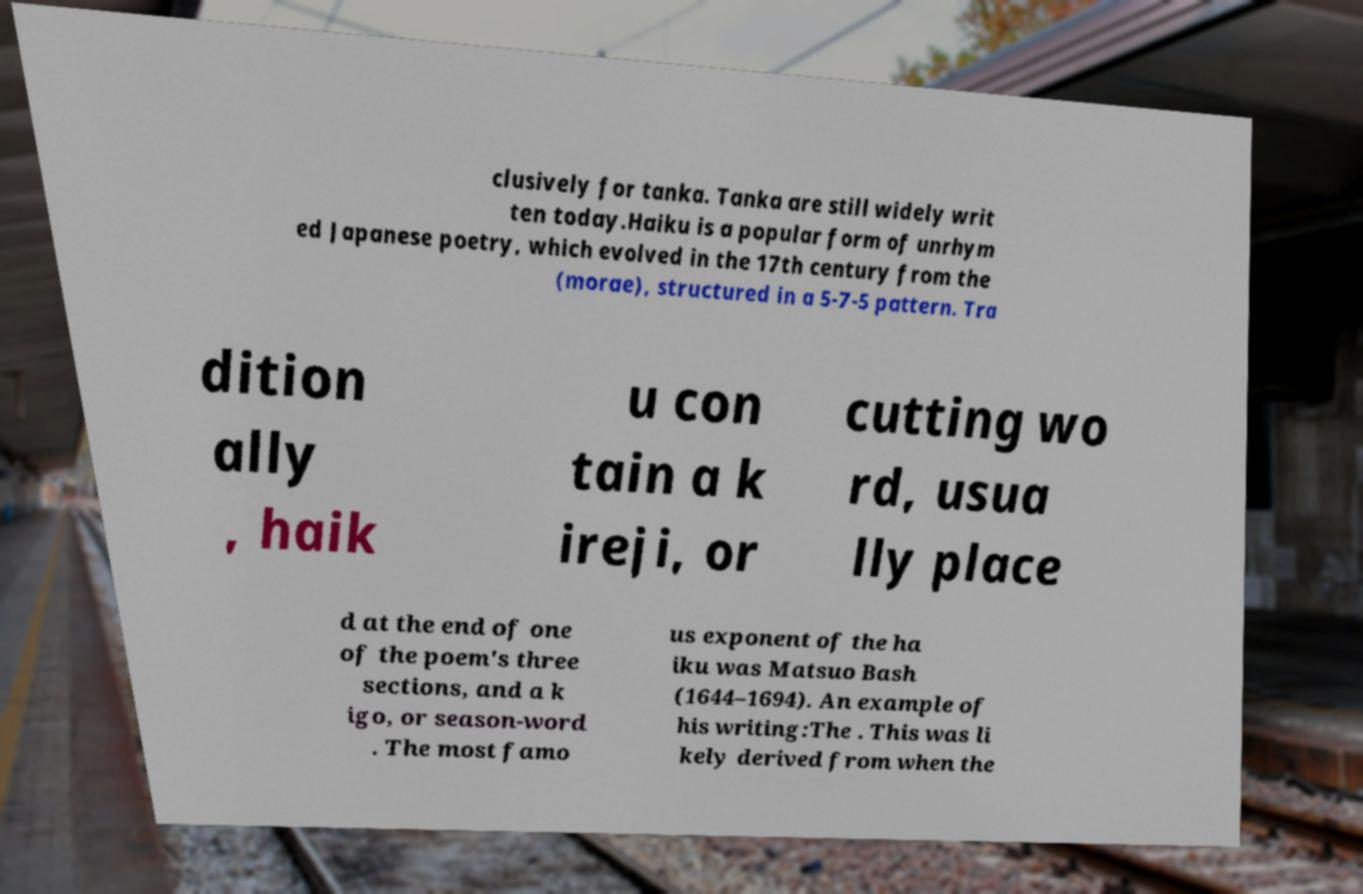For documentation purposes, I need the text within this image transcribed. Could you provide that? clusively for tanka. Tanka are still widely writ ten today.Haiku is a popular form of unrhym ed Japanese poetry, which evolved in the 17th century from the (morae), structured in a 5-7-5 pattern. Tra dition ally , haik u con tain a k ireji, or cutting wo rd, usua lly place d at the end of one of the poem's three sections, and a k igo, or season-word . The most famo us exponent of the ha iku was Matsuo Bash (1644–1694). An example of his writing:The . This was li kely derived from when the 